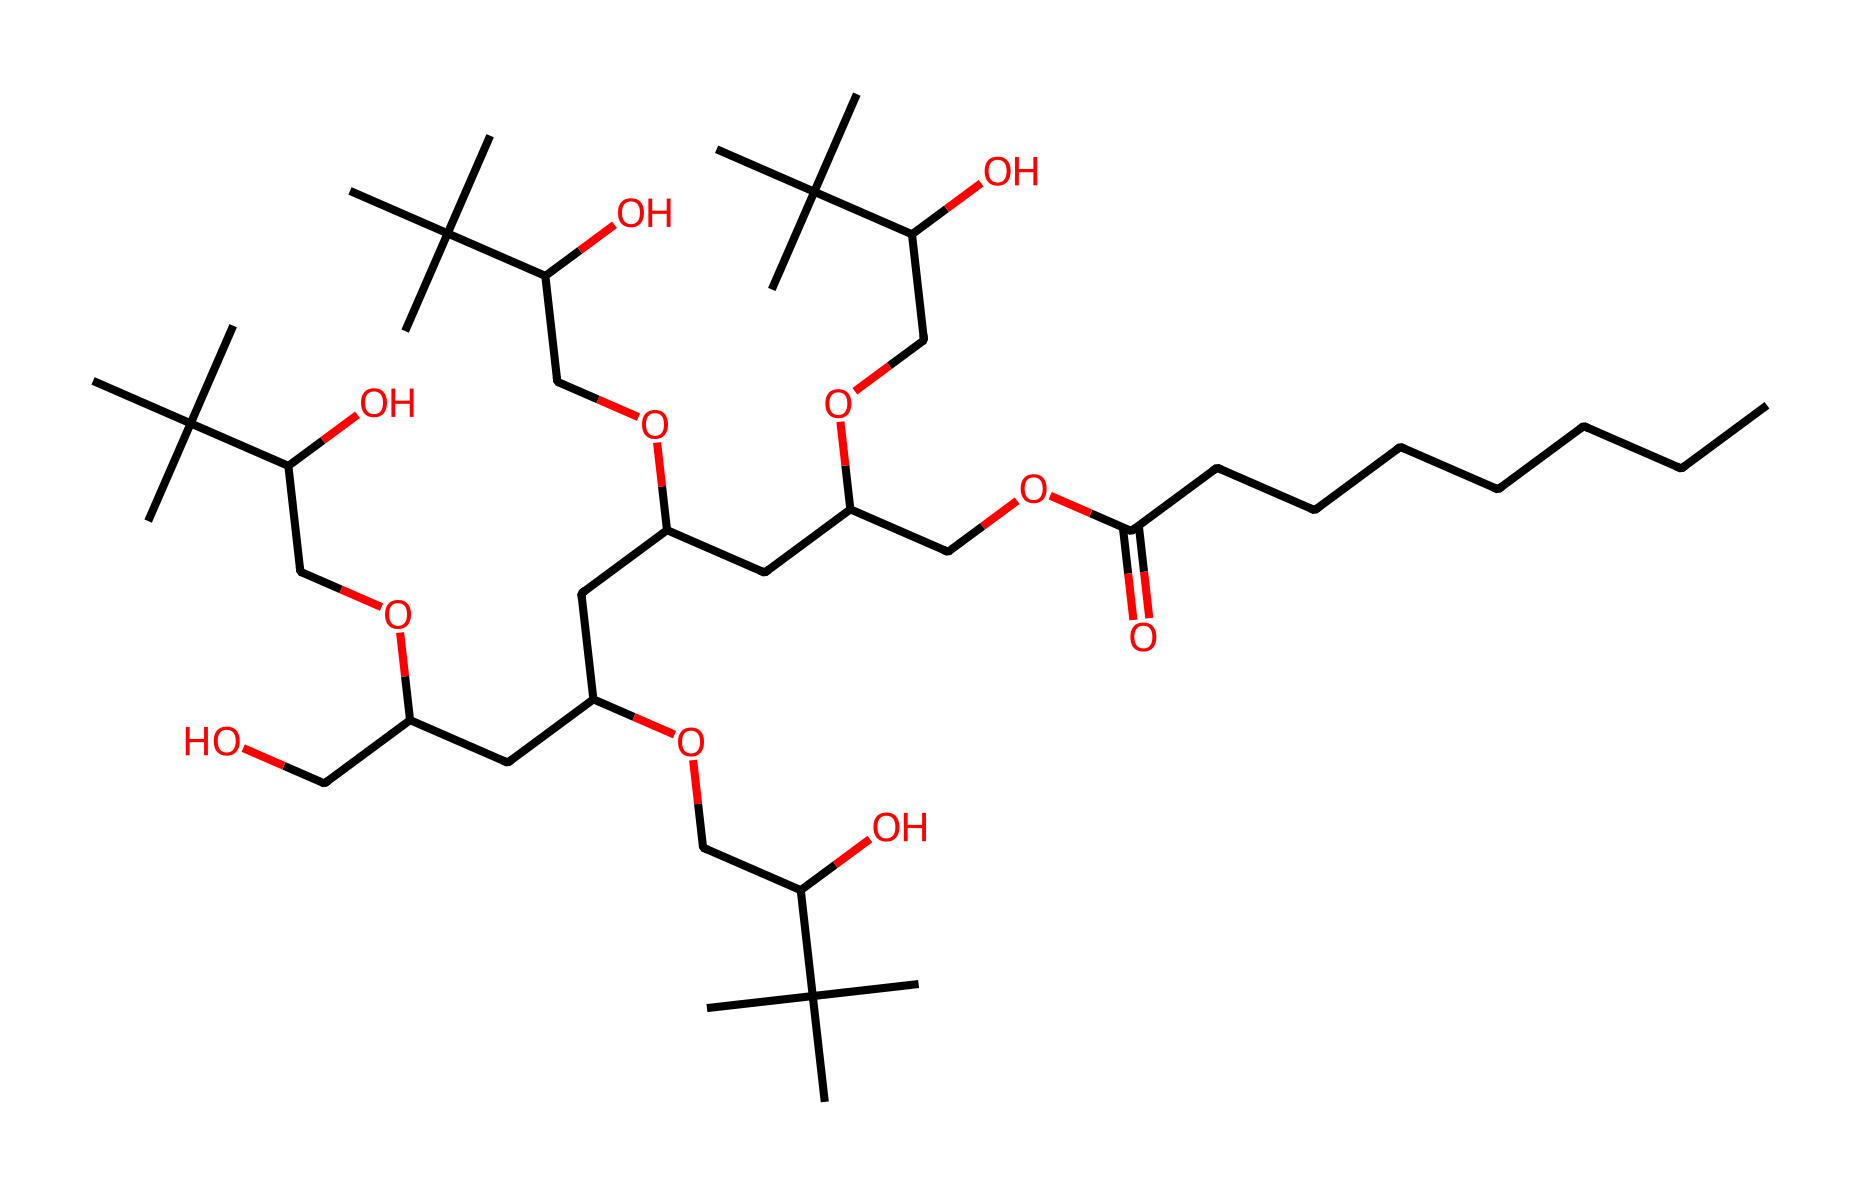What is the molecular formula for polysorbate 80? The SMILES representation indicates several types of atoms, primarily including carbon, hydrogen, and oxygen. By counting the number of carbons, hydrogens, and oxygens represented in the structure, the molecular formula is derived as C24H44O13.
Answer: C24H44O13 How many carbon atoms are present in this structure? The structure shows multiple carbon chains and branched structures. Counting the carbon atoms from the SMILES representation yields a total of 24 carbon atoms.
Answer: 24 Which functional groups are present in polysorbate 80? The SMILES representation contains ester (-COO-) and alcohol (-OH) functional groups, evident from the presence of the oxygen and carbonyl sections in the structure.
Answer: ester and alcohol What physical property is affected by the long carbon chain in polysorbate 80? The long carbon chain contributes to the molecule's hydrophobic characteristics, affecting its solubility in water and emulsifying properties.
Answer: hydrophobicity How does the structure of polysorbate 80 contribute to its surfactant properties? The presence of both hydrophobic long carbon chains and hydrophilic alcohol groups allows polysorbate 80 to reduce surface tension between liquids, enabling it to function effectively as a surfactant.
Answer: surface tension reduction How many hydroxyl groups are present in this compound? By analyzing the SMILES representation, the number of -OH (hydroxyl) groups is determined by locating every occurrence of -O and noting those attached to carbons, leading to a total of 10 hydroxyl groups.
Answer: 10 What is the role of polysorbate 80 in sports drinks? Polysorbate 80 serves as an emulsifier, helping to stabilize mixtures of oil and water, which is essential for maintaining product consistency in sports drinks.
Answer: emulsifier 